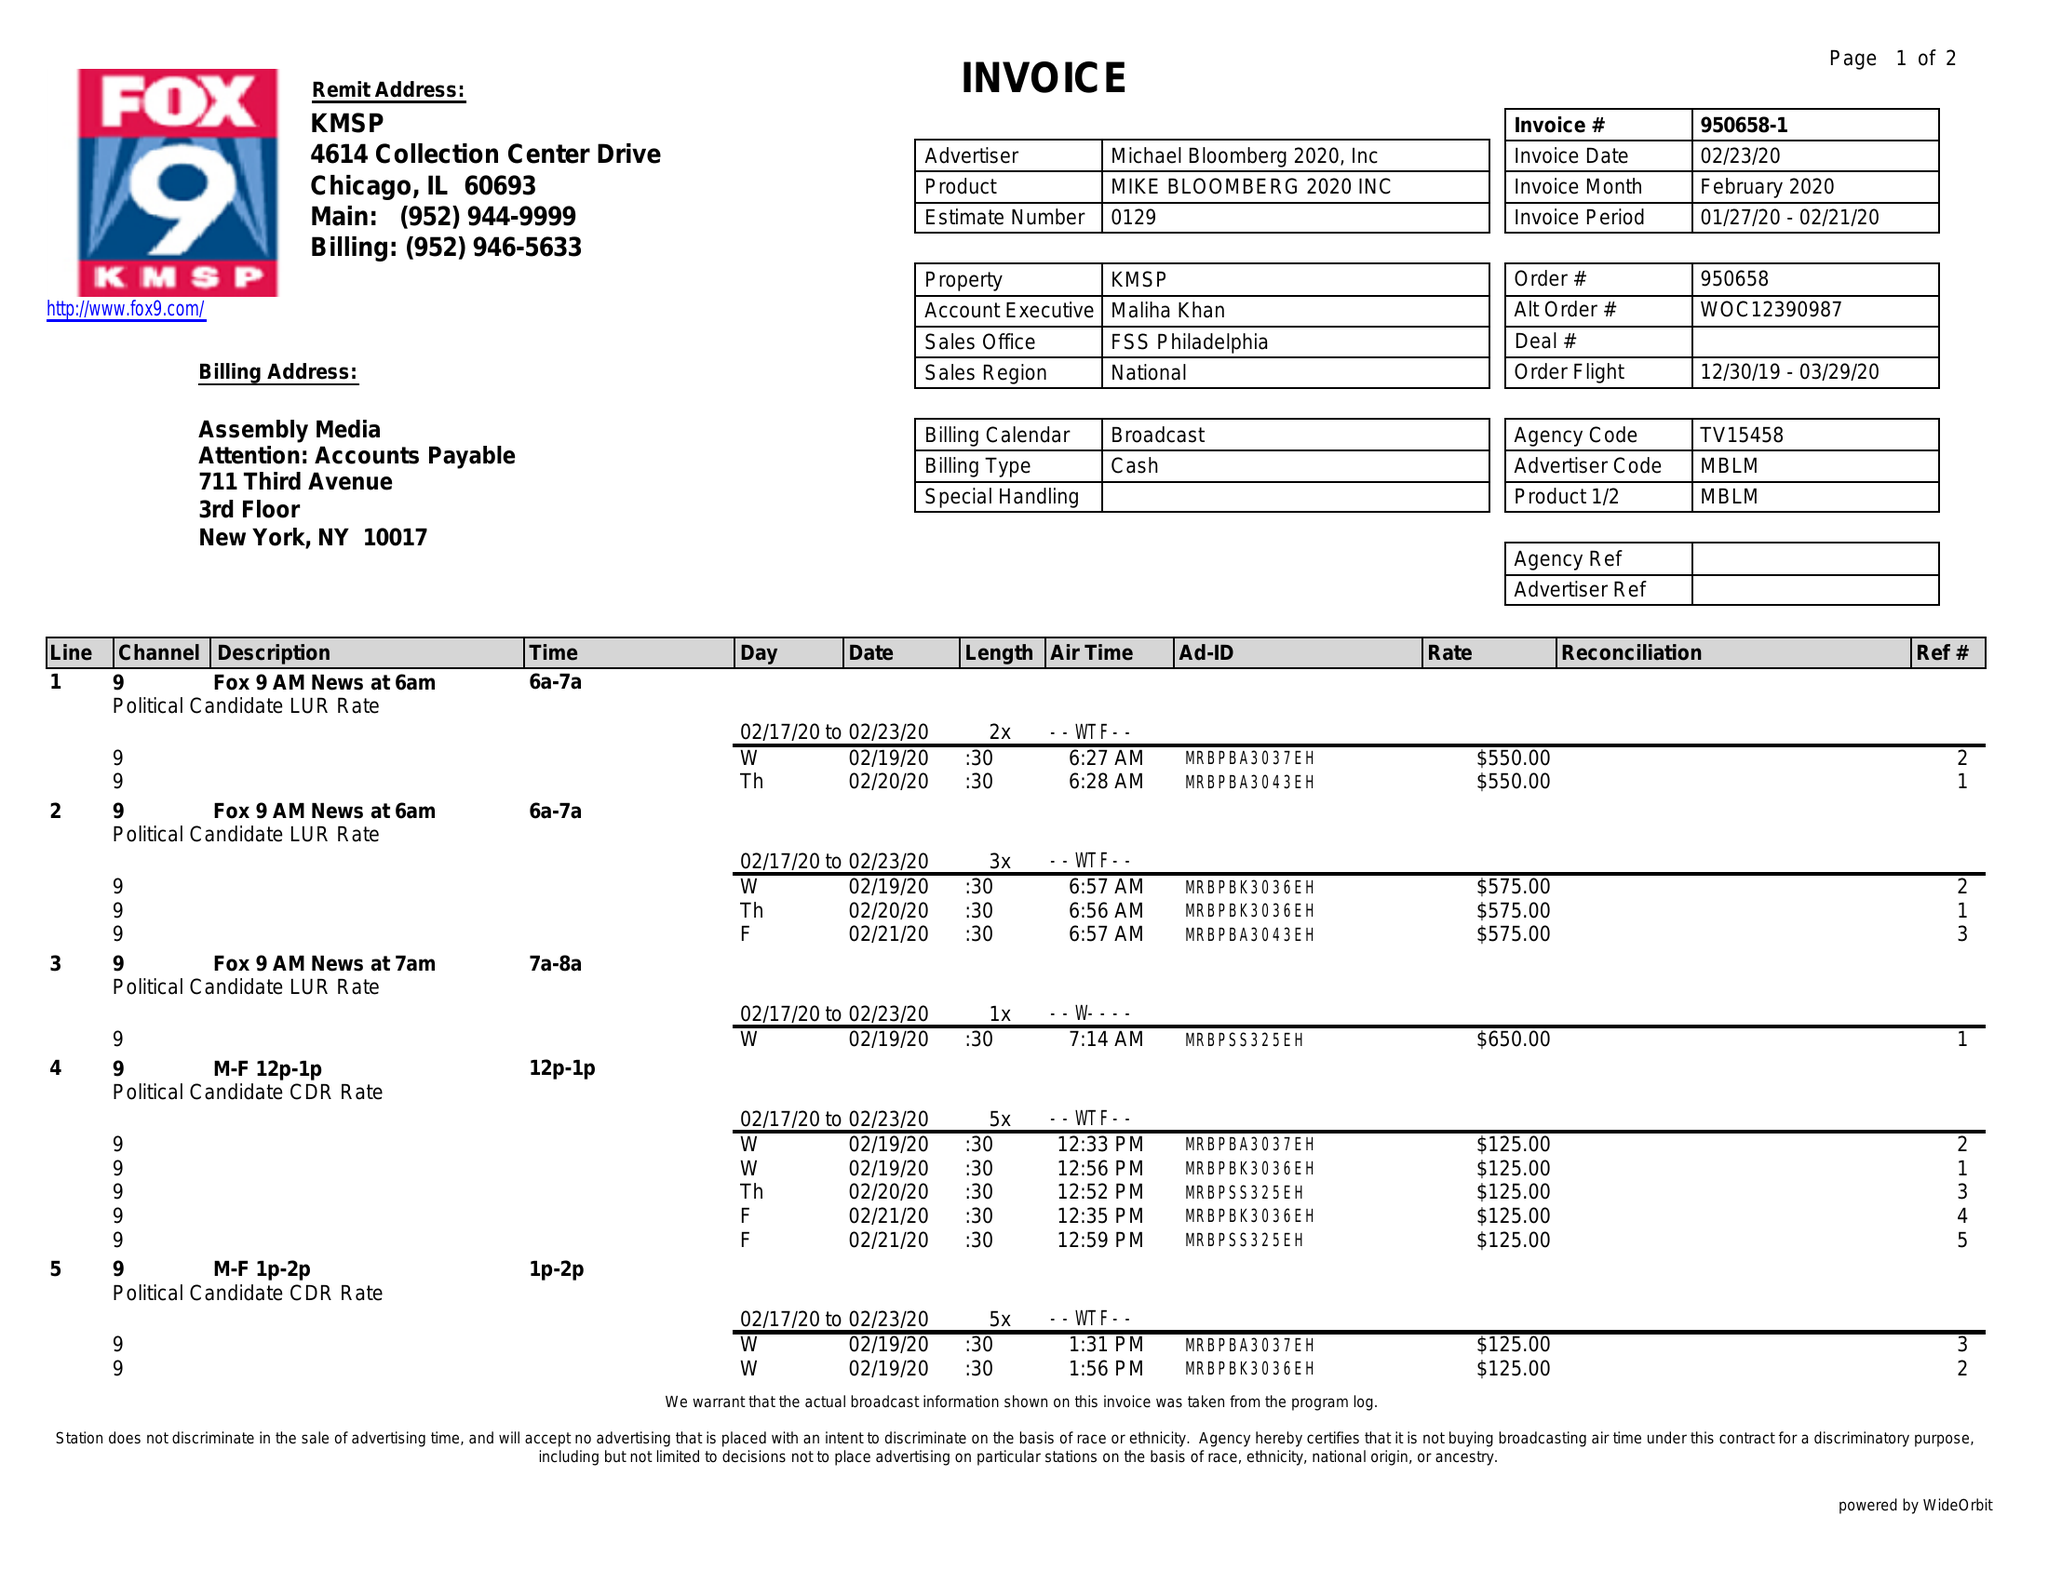What is the value for the flight_to?
Answer the question using a single word or phrase. 03/29/20 